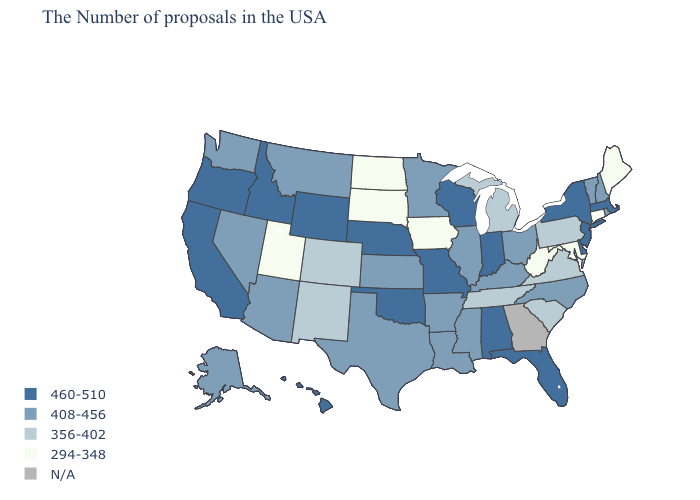Name the states that have a value in the range 356-402?
Short answer required. Pennsylvania, Virginia, South Carolina, Michigan, Tennessee, Colorado, New Mexico. What is the highest value in the USA?
Keep it brief. 460-510. Does Louisiana have the lowest value in the USA?
Concise answer only. No. What is the lowest value in states that border Vermont?
Answer briefly. 408-456. Name the states that have a value in the range 356-402?
Short answer required. Pennsylvania, Virginia, South Carolina, Michigan, Tennessee, Colorado, New Mexico. Does the first symbol in the legend represent the smallest category?
Short answer required. No. Name the states that have a value in the range 294-348?
Keep it brief. Maine, Connecticut, Maryland, West Virginia, Iowa, South Dakota, North Dakota, Utah. Name the states that have a value in the range 356-402?
Be succinct. Pennsylvania, Virginia, South Carolina, Michigan, Tennessee, Colorado, New Mexico. Which states have the lowest value in the West?
Be succinct. Utah. Does the first symbol in the legend represent the smallest category?
Give a very brief answer. No. Among the states that border Idaho , which have the highest value?
Concise answer only. Wyoming, Oregon. How many symbols are there in the legend?
Quick response, please. 5. Does New Jersey have the lowest value in the USA?
Concise answer only. No. What is the value of Indiana?
Write a very short answer. 460-510. 